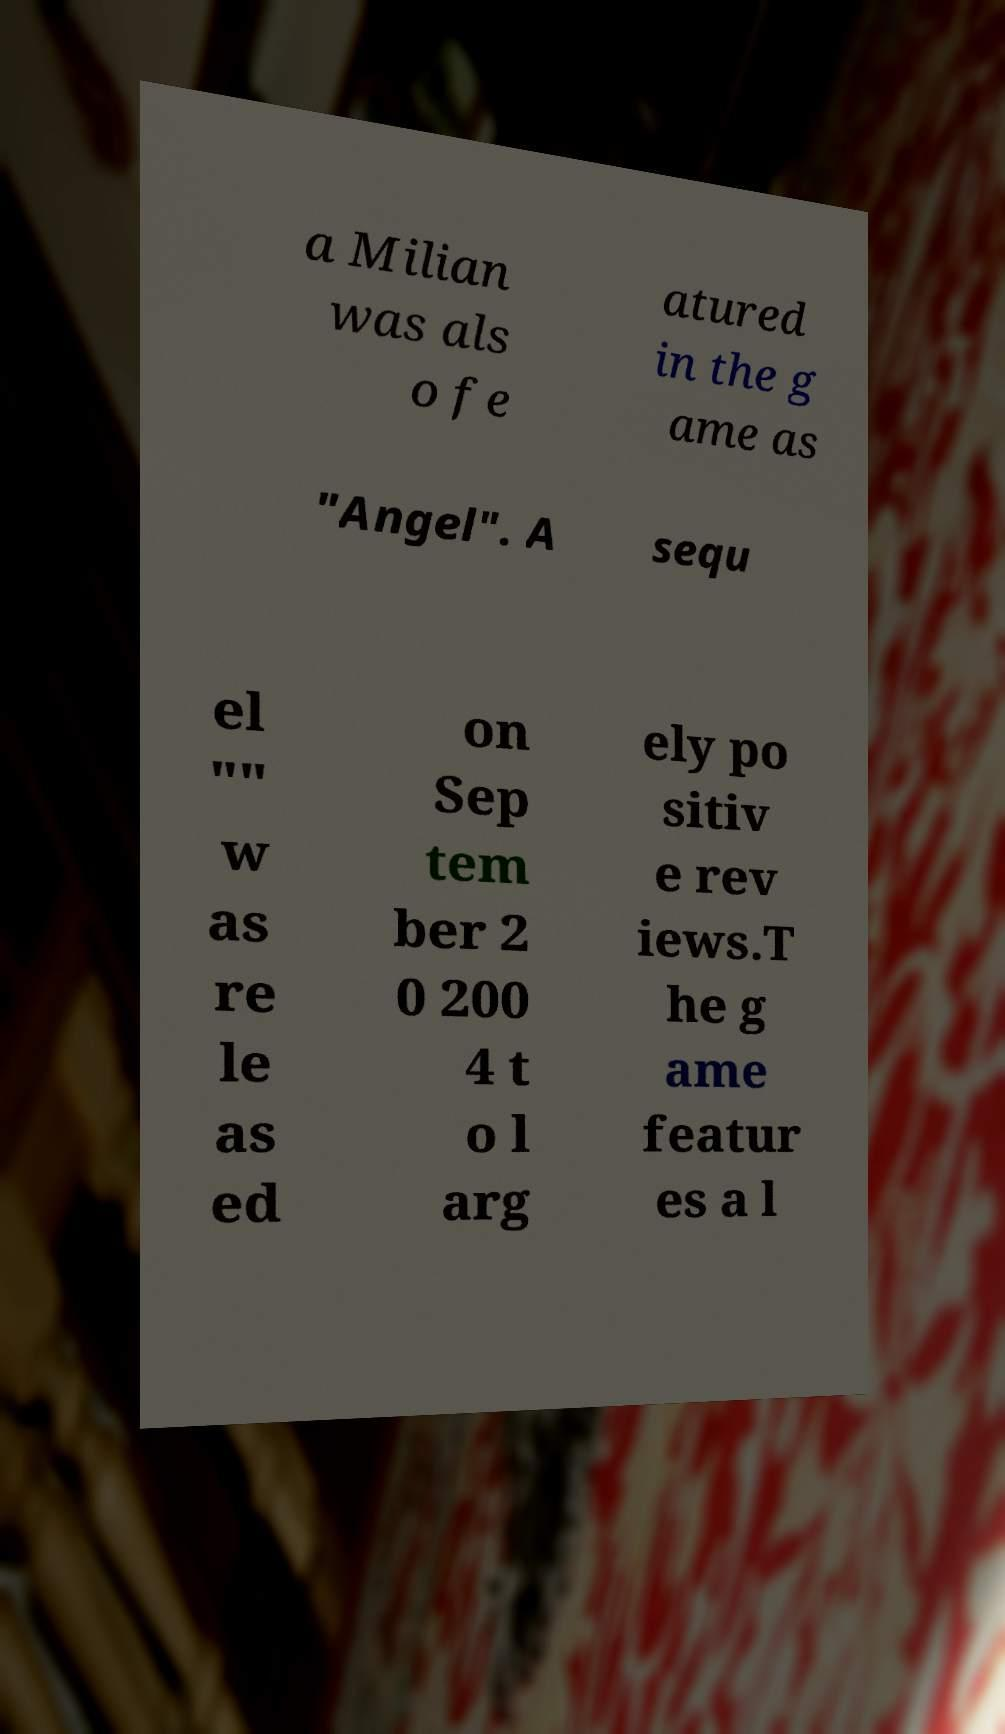There's text embedded in this image that I need extracted. Can you transcribe it verbatim? a Milian was als o fe atured in the g ame as "Angel". A sequ el "" w as re le as ed on Sep tem ber 2 0 200 4 t o l arg ely po sitiv e rev iews.T he g ame featur es a l 